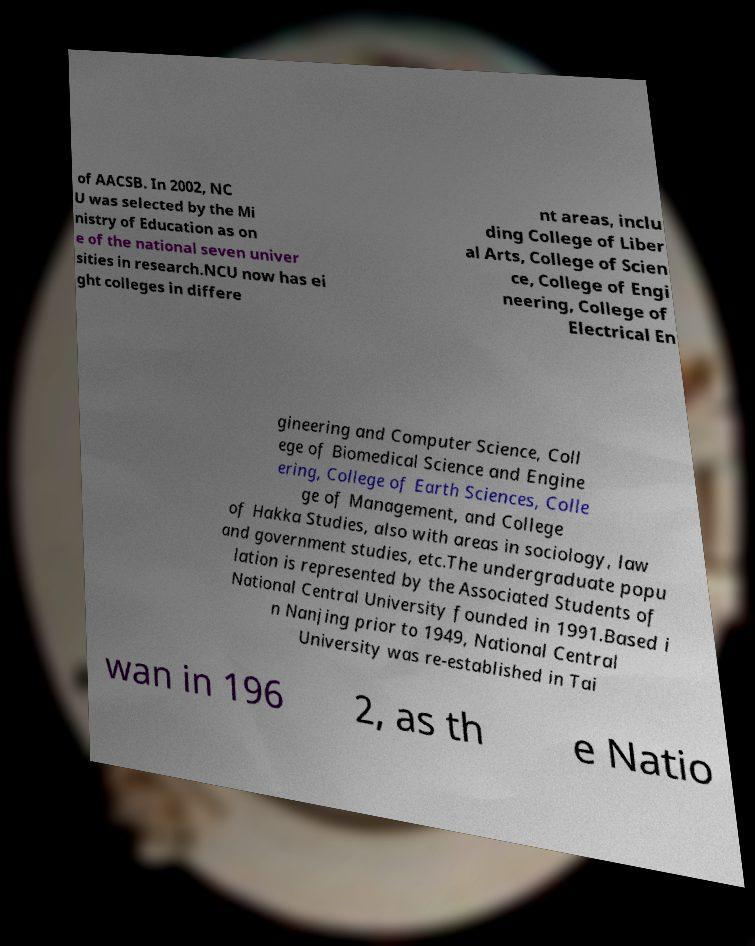Please read and relay the text visible in this image. What does it say? of AACSB. In 2002, NC U was selected by the Mi nistry of Education as on e of the national seven univer sities in research.NCU now has ei ght colleges in differe nt areas, inclu ding College of Liber al Arts, College of Scien ce, College of Engi neering, College of Electrical En gineering and Computer Science, Coll ege of Biomedical Science and Engine ering, College of Earth Sciences, Colle ge of Management, and College of Hakka Studies, also with areas in sociology, law and government studies, etc.The undergraduate popu lation is represented by the Associated Students of National Central University founded in 1991.Based i n Nanjing prior to 1949, National Central University was re-established in Tai wan in 196 2, as th e Natio 